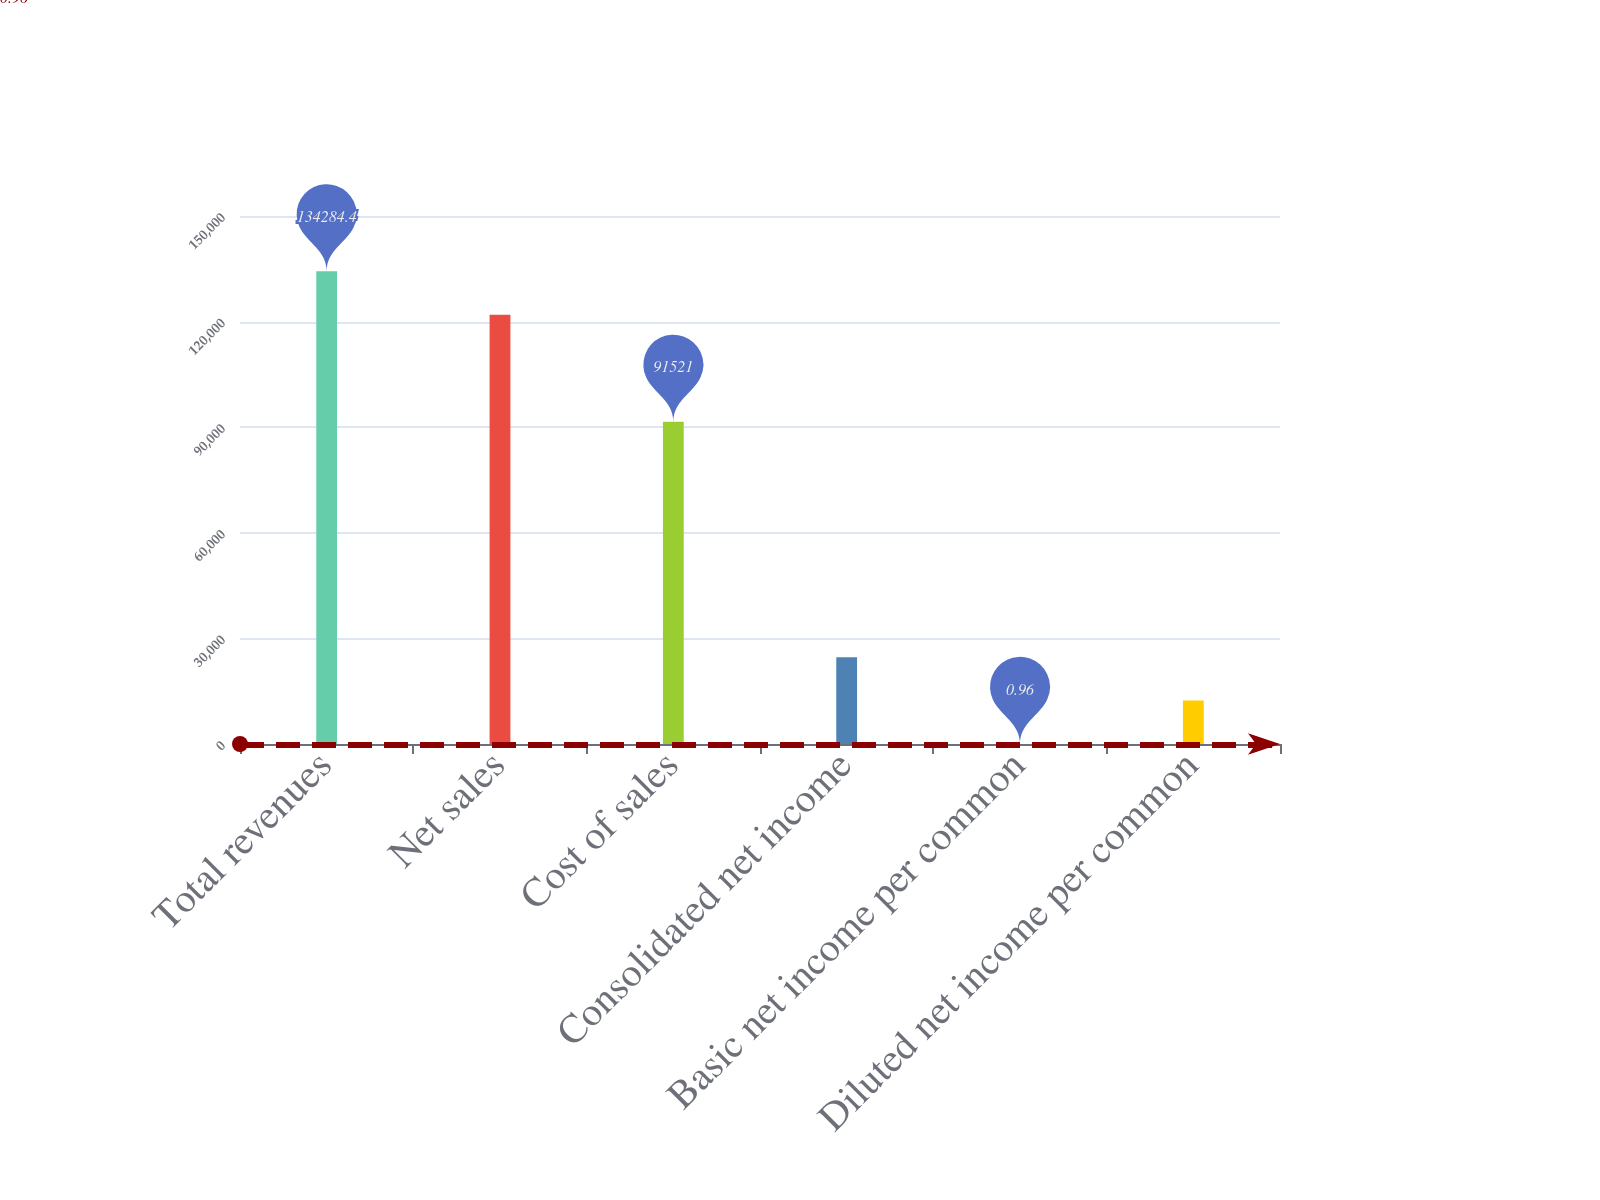Convert chart. <chart><loc_0><loc_0><loc_500><loc_500><bar_chart><fcel>Total revenues<fcel>Net sales<fcel>Cost of sales<fcel>Consolidated net income<fcel>Basic net income per common<fcel>Diluted net income per common<nl><fcel>134284<fcel>121949<fcel>91521<fcel>24671.8<fcel>0.96<fcel>12336.4<nl></chart> 